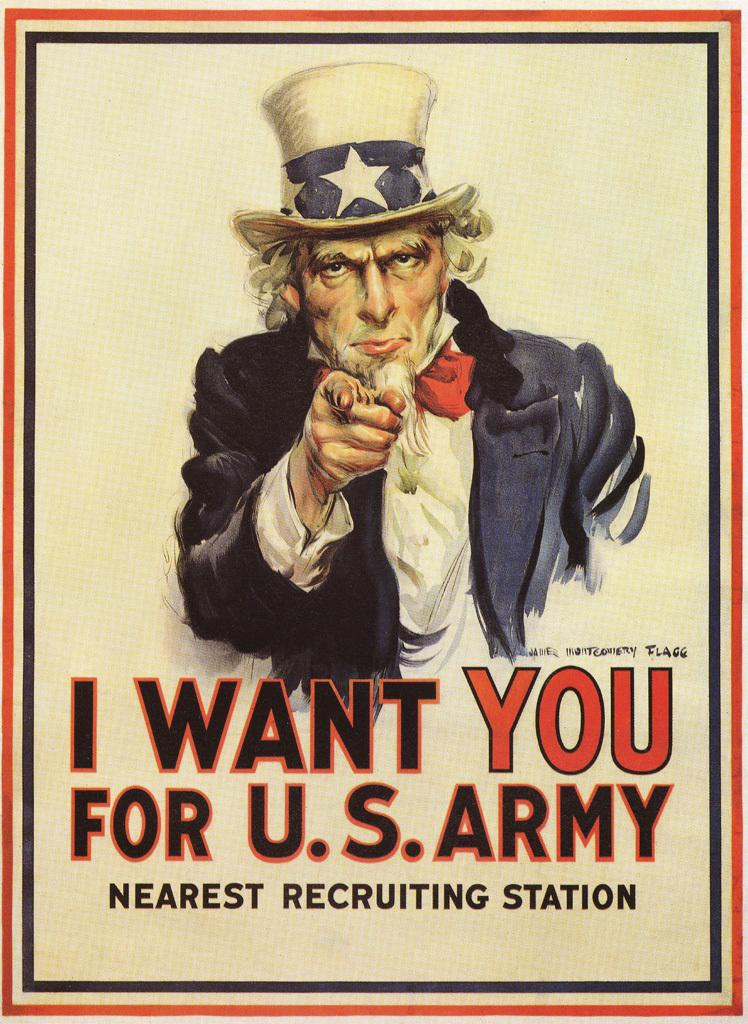<image>
Describe the image concisely. A poster showing a man pointing and says I Want You For U.S. Army. 